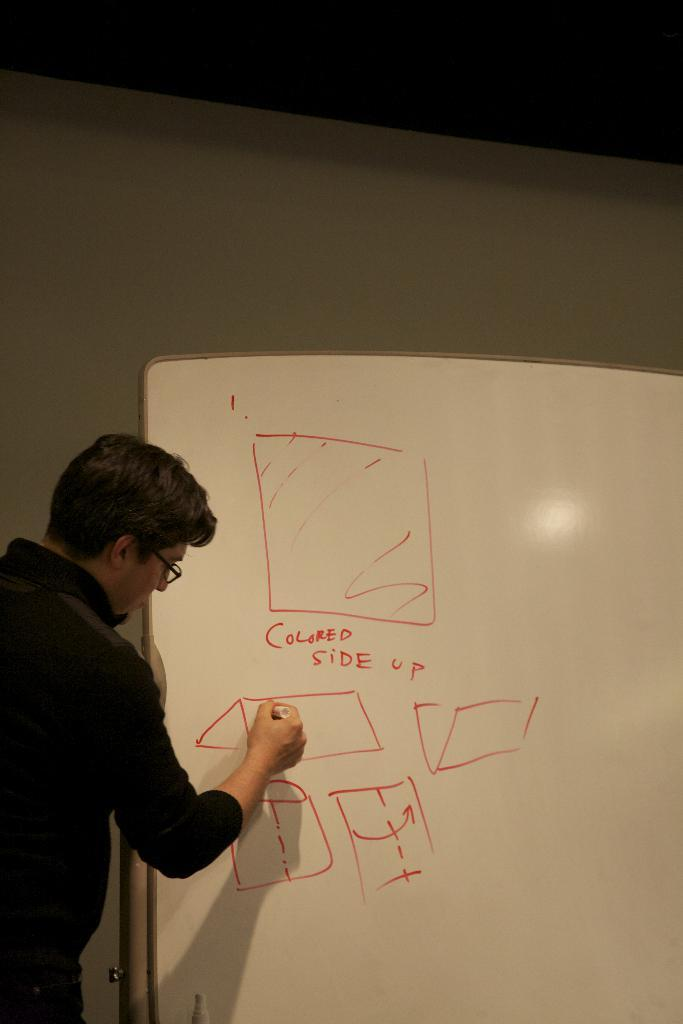<image>
Offer a succinct explanation of the picture presented. A man writes on a white board that has colored side up written in red. 